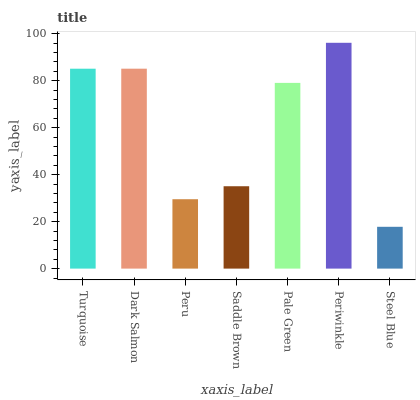Is Steel Blue the minimum?
Answer yes or no. Yes. Is Periwinkle the maximum?
Answer yes or no. Yes. Is Dark Salmon the minimum?
Answer yes or no. No. Is Dark Salmon the maximum?
Answer yes or no. No. Is Dark Salmon greater than Turquoise?
Answer yes or no. Yes. Is Turquoise less than Dark Salmon?
Answer yes or no. Yes. Is Turquoise greater than Dark Salmon?
Answer yes or no. No. Is Dark Salmon less than Turquoise?
Answer yes or no. No. Is Pale Green the high median?
Answer yes or no. Yes. Is Pale Green the low median?
Answer yes or no. Yes. Is Periwinkle the high median?
Answer yes or no. No. Is Turquoise the low median?
Answer yes or no. No. 